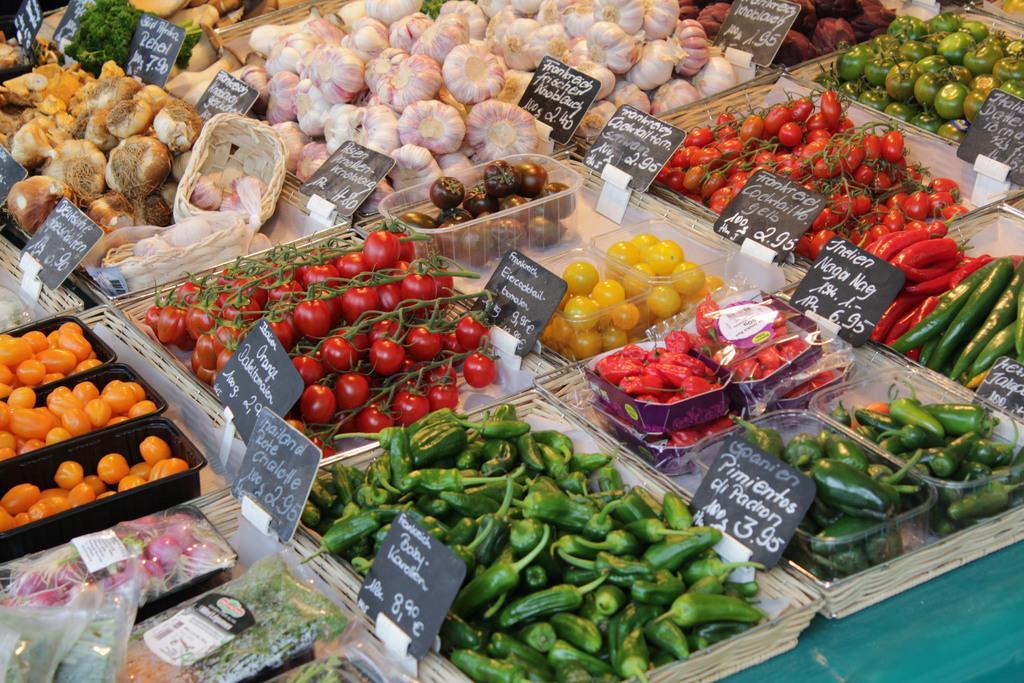Please provide a concise description of this image. In this picture we can see there are trays and on the trays there are different kinds of vegetables with the price boards. 